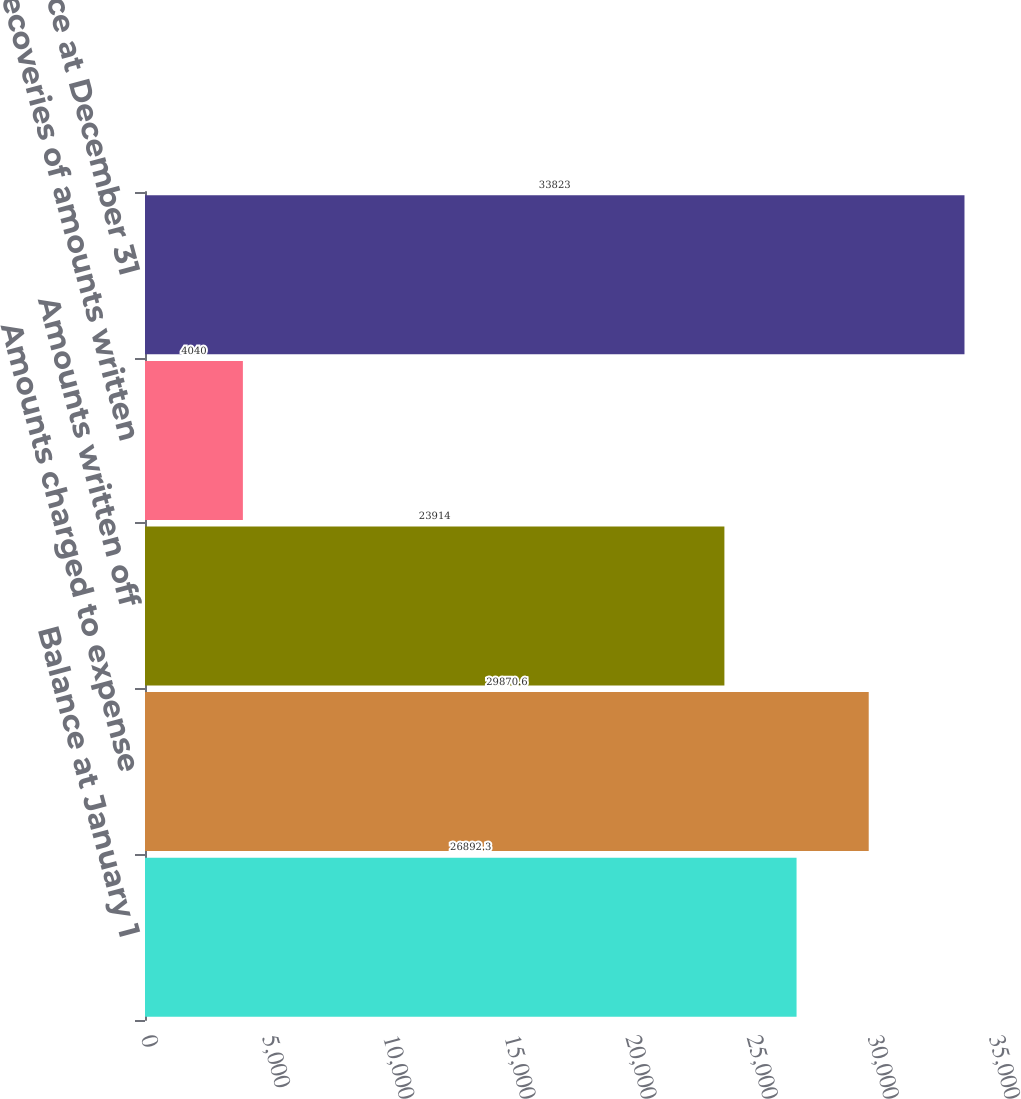<chart> <loc_0><loc_0><loc_500><loc_500><bar_chart><fcel>Balance at January 1<fcel>Amounts charged to expense<fcel>Amounts written off<fcel>Recoveries of amounts written<fcel>Balance at December 31<nl><fcel>26892.3<fcel>29870.6<fcel>23914<fcel>4040<fcel>33823<nl></chart> 